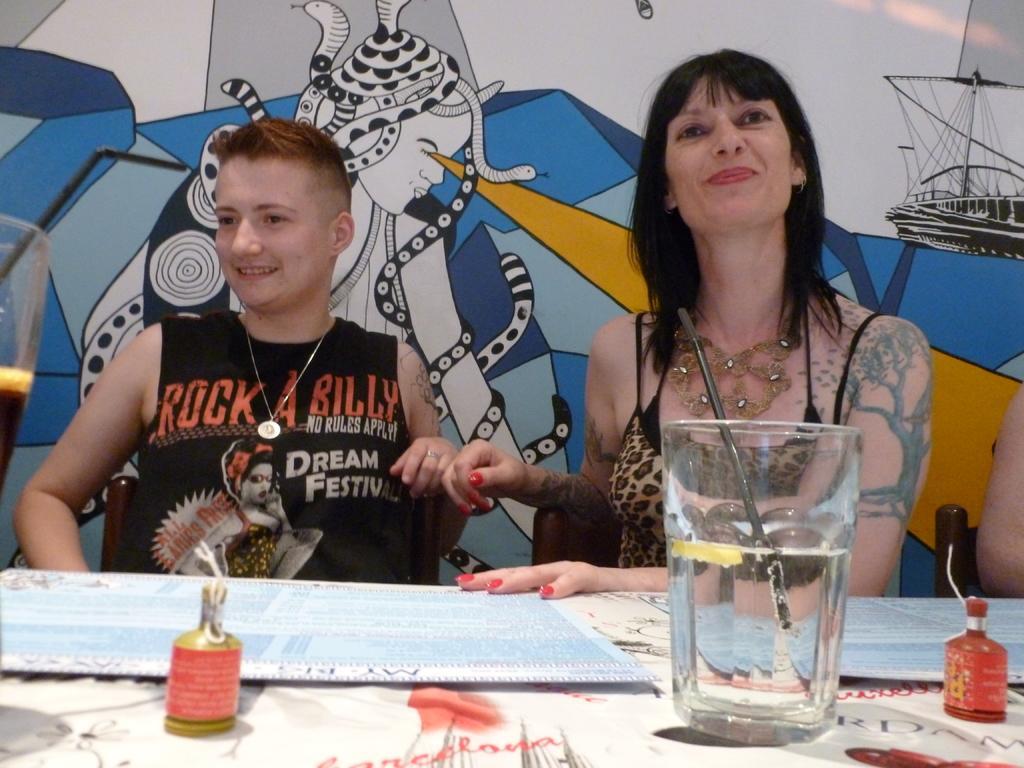Please provide a concise description of this image. On the right there is a woman who is wearing dress. She is sitting on the chair, beside that we can see a boy who is wearing black t-shirt and locket. He is sitting near to the table. On the table we can see water glass, mic, bottles and paper. In the back we can see the painted wall. 